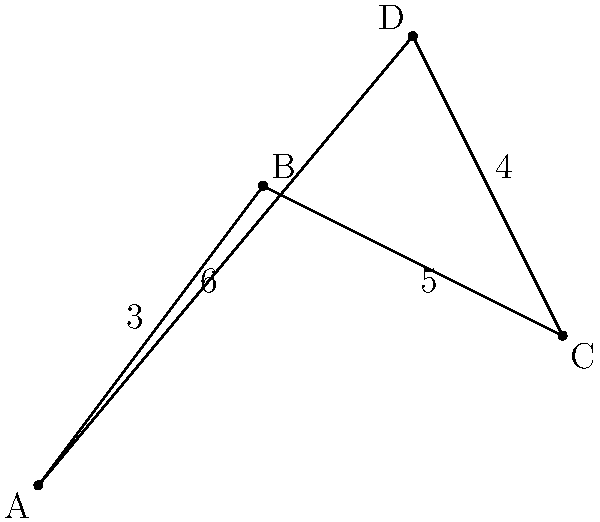As a runner, you're planning a new training route that connects four checkpoints (A, B, C, and D) in a city. The distances between consecutive checkpoints are shown in the diagram (in kilometers). What is the total distance of the route if you start at point A and finish at point D, visiting each checkpoint exactly once? To find the total distance of the route, we need to add up the distances between consecutive checkpoints from A to D. Let's break it down step-by-step:

1. Distance from A to B: 3 km
2. Distance from B to C: 5 km
3. Distance from C to D: 4 km

Now, we simply add these distances:

$$ \text{Total distance} = 3 \text{ km} + 5 \text{ km} + 4 \text{ km} = 12 \text{ km} $$

Note that we don't include the distance from D back to A (6 km) because the question asks for the route from A to D, not a complete loop.
Answer: 12 km 